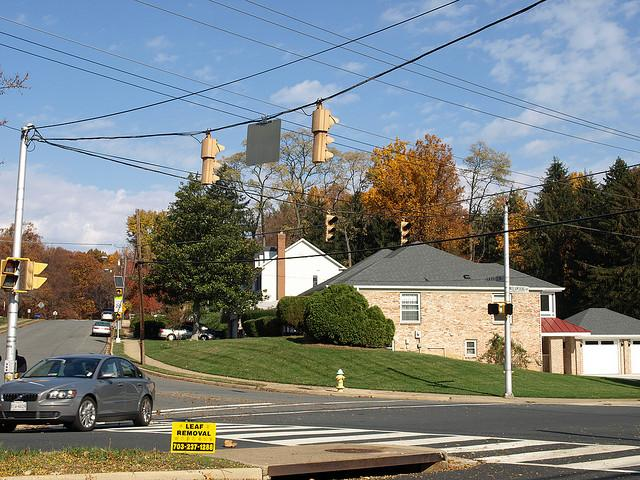What kind of trash can the company advertising on yellow sign help with? Please explain your reasoning. leaf. The trash is for leaves. 